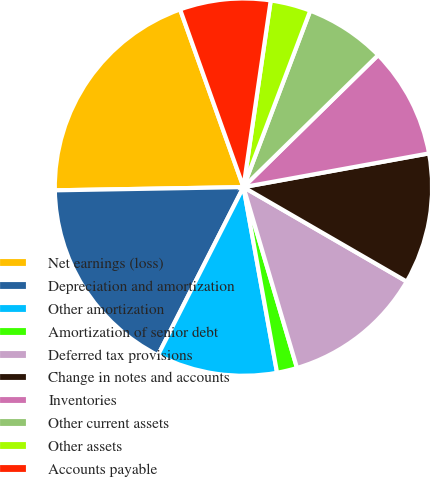<chart> <loc_0><loc_0><loc_500><loc_500><pie_chart><fcel>Net earnings (loss)<fcel>Depreciation and amortization<fcel>Other amortization<fcel>Amortization of senior debt<fcel>Deferred tax provisions<fcel>Change in notes and accounts<fcel>Inventories<fcel>Other current assets<fcel>Other assets<fcel>Accounts payable<nl><fcel>19.82%<fcel>17.24%<fcel>10.34%<fcel>1.73%<fcel>12.07%<fcel>11.21%<fcel>9.48%<fcel>6.9%<fcel>3.45%<fcel>7.76%<nl></chart> 